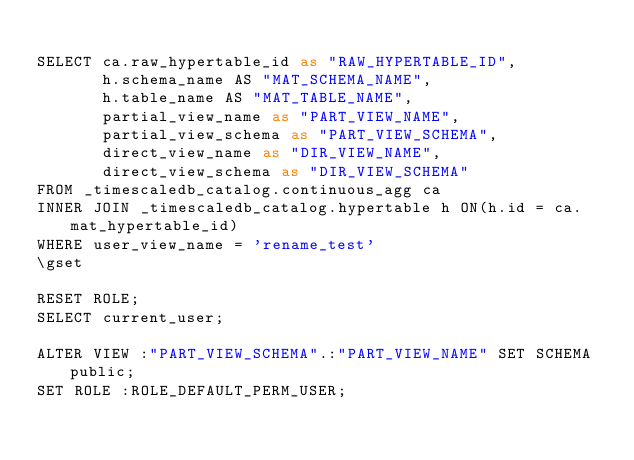<code> <loc_0><loc_0><loc_500><loc_500><_SQL_>
SELECT ca.raw_hypertable_id as "RAW_HYPERTABLE_ID",
       h.schema_name AS "MAT_SCHEMA_NAME",
       h.table_name AS "MAT_TABLE_NAME",
       partial_view_name as "PART_VIEW_NAME",
       partial_view_schema as "PART_VIEW_SCHEMA",
       direct_view_name as "DIR_VIEW_NAME",
       direct_view_schema as "DIR_VIEW_SCHEMA"
FROM _timescaledb_catalog.continuous_agg ca
INNER JOIN _timescaledb_catalog.hypertable h ON(h.id = ca.mat_hypertable_id)
WHERE user_view_name = 'rename_test'
\gset

RESET ROLE;
SELECT current_user;

ALTER VIEW :"PART_VIEW_SCHEMA".:"PART_VIEW_NAME" SET SCHEMA public;
SET ROLE :ROLE_DEFAULT_PERM_USER;
</code> 